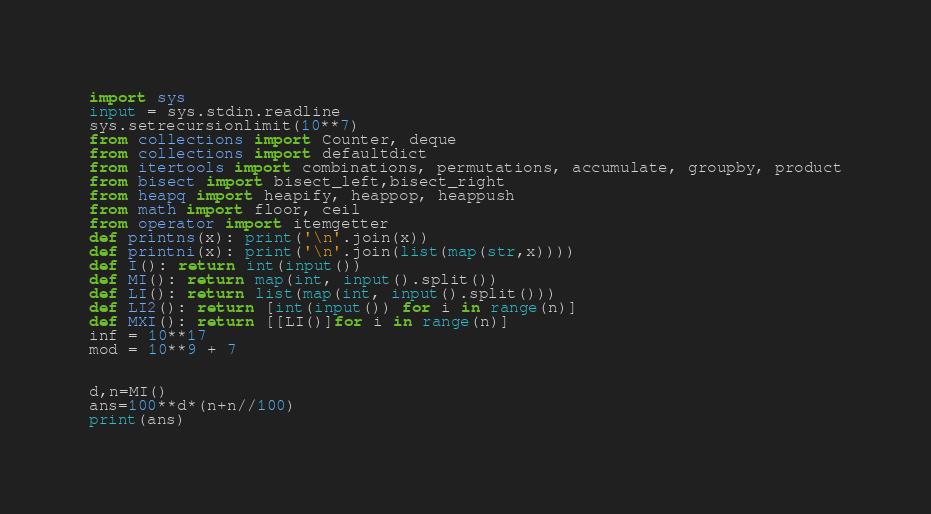<code> <loc_0><loc_0><loc_500><loc_500><_Python_>import sys
input = sys.stdin.readline
sys.setrecursionlimit(10**7)
from collections import Counter, deque
from collections import defaultdict
from itertools import combinations, permutations, accumulate, groupby, product
from bisect import bisect_left,bisect_right
from heapq import heapify, heappop, heappush
from math import floor, ceil
from operator import itemgetter
def printns(x): print('\n'.join(x))
def printni(x): print('\n'.join(list(map(str,x))))
def I(): return int(input())
def MI(): return map(int, input().split())
def LI(): return list(map(int, input().split()))
def LI2(): return [int(input()) for i in range(n)]
def MXI(): return [[LI()]for i in range(n)]
inf = 10**17
mod = 10**9 + 7


d,n=MI()
ans=100**d*(n+n//100)
print(ans)</code> 